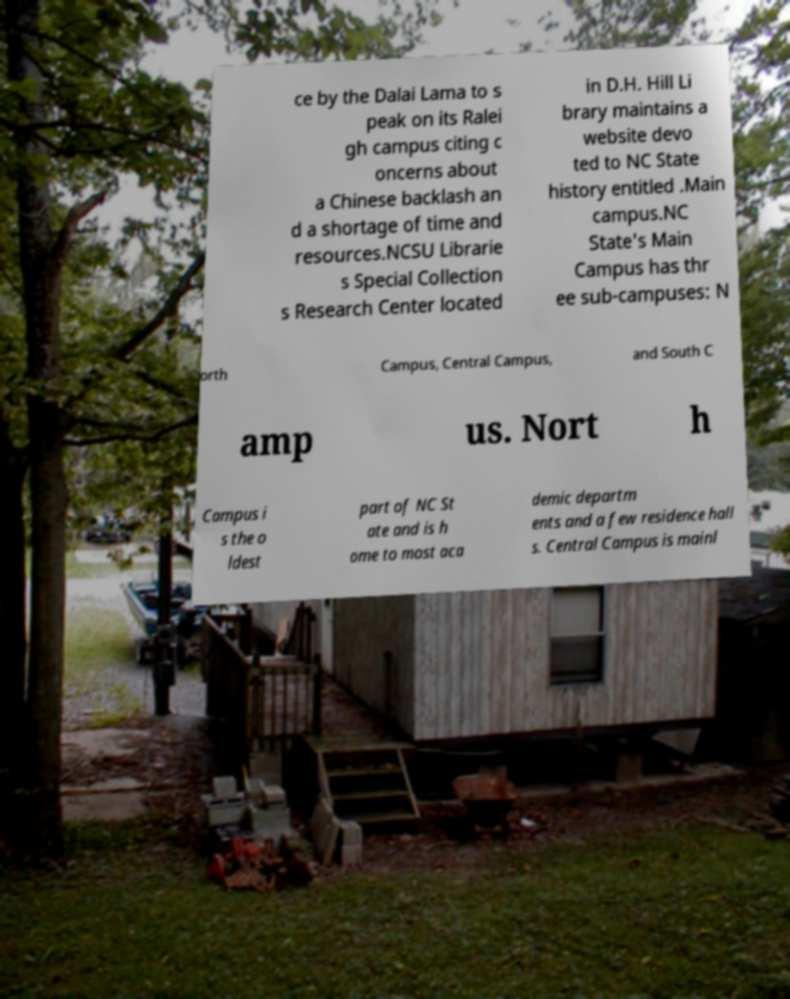For documentation purposes, I need the text within this image transcribed. Could you provide that? ce by the Dalai Lama to s peak on its Ralei gh campus citing c oncerns about a Chinese backlash an d a shortage of time and resources.NCSU Librarie s Special Collection s Research Center located in D.H. Hill Li brary maintains a website devo ted to NC State history entitled .Main campus.NC State's Main Campus has thr ee sub-campuses: N orth Campus, Central Campus, and South C amp us. Nort h Campus i s the o ldest part of NC St ate and is h ome to most aca demic departm ents and a few residence hall s. Central Campus is mainl 